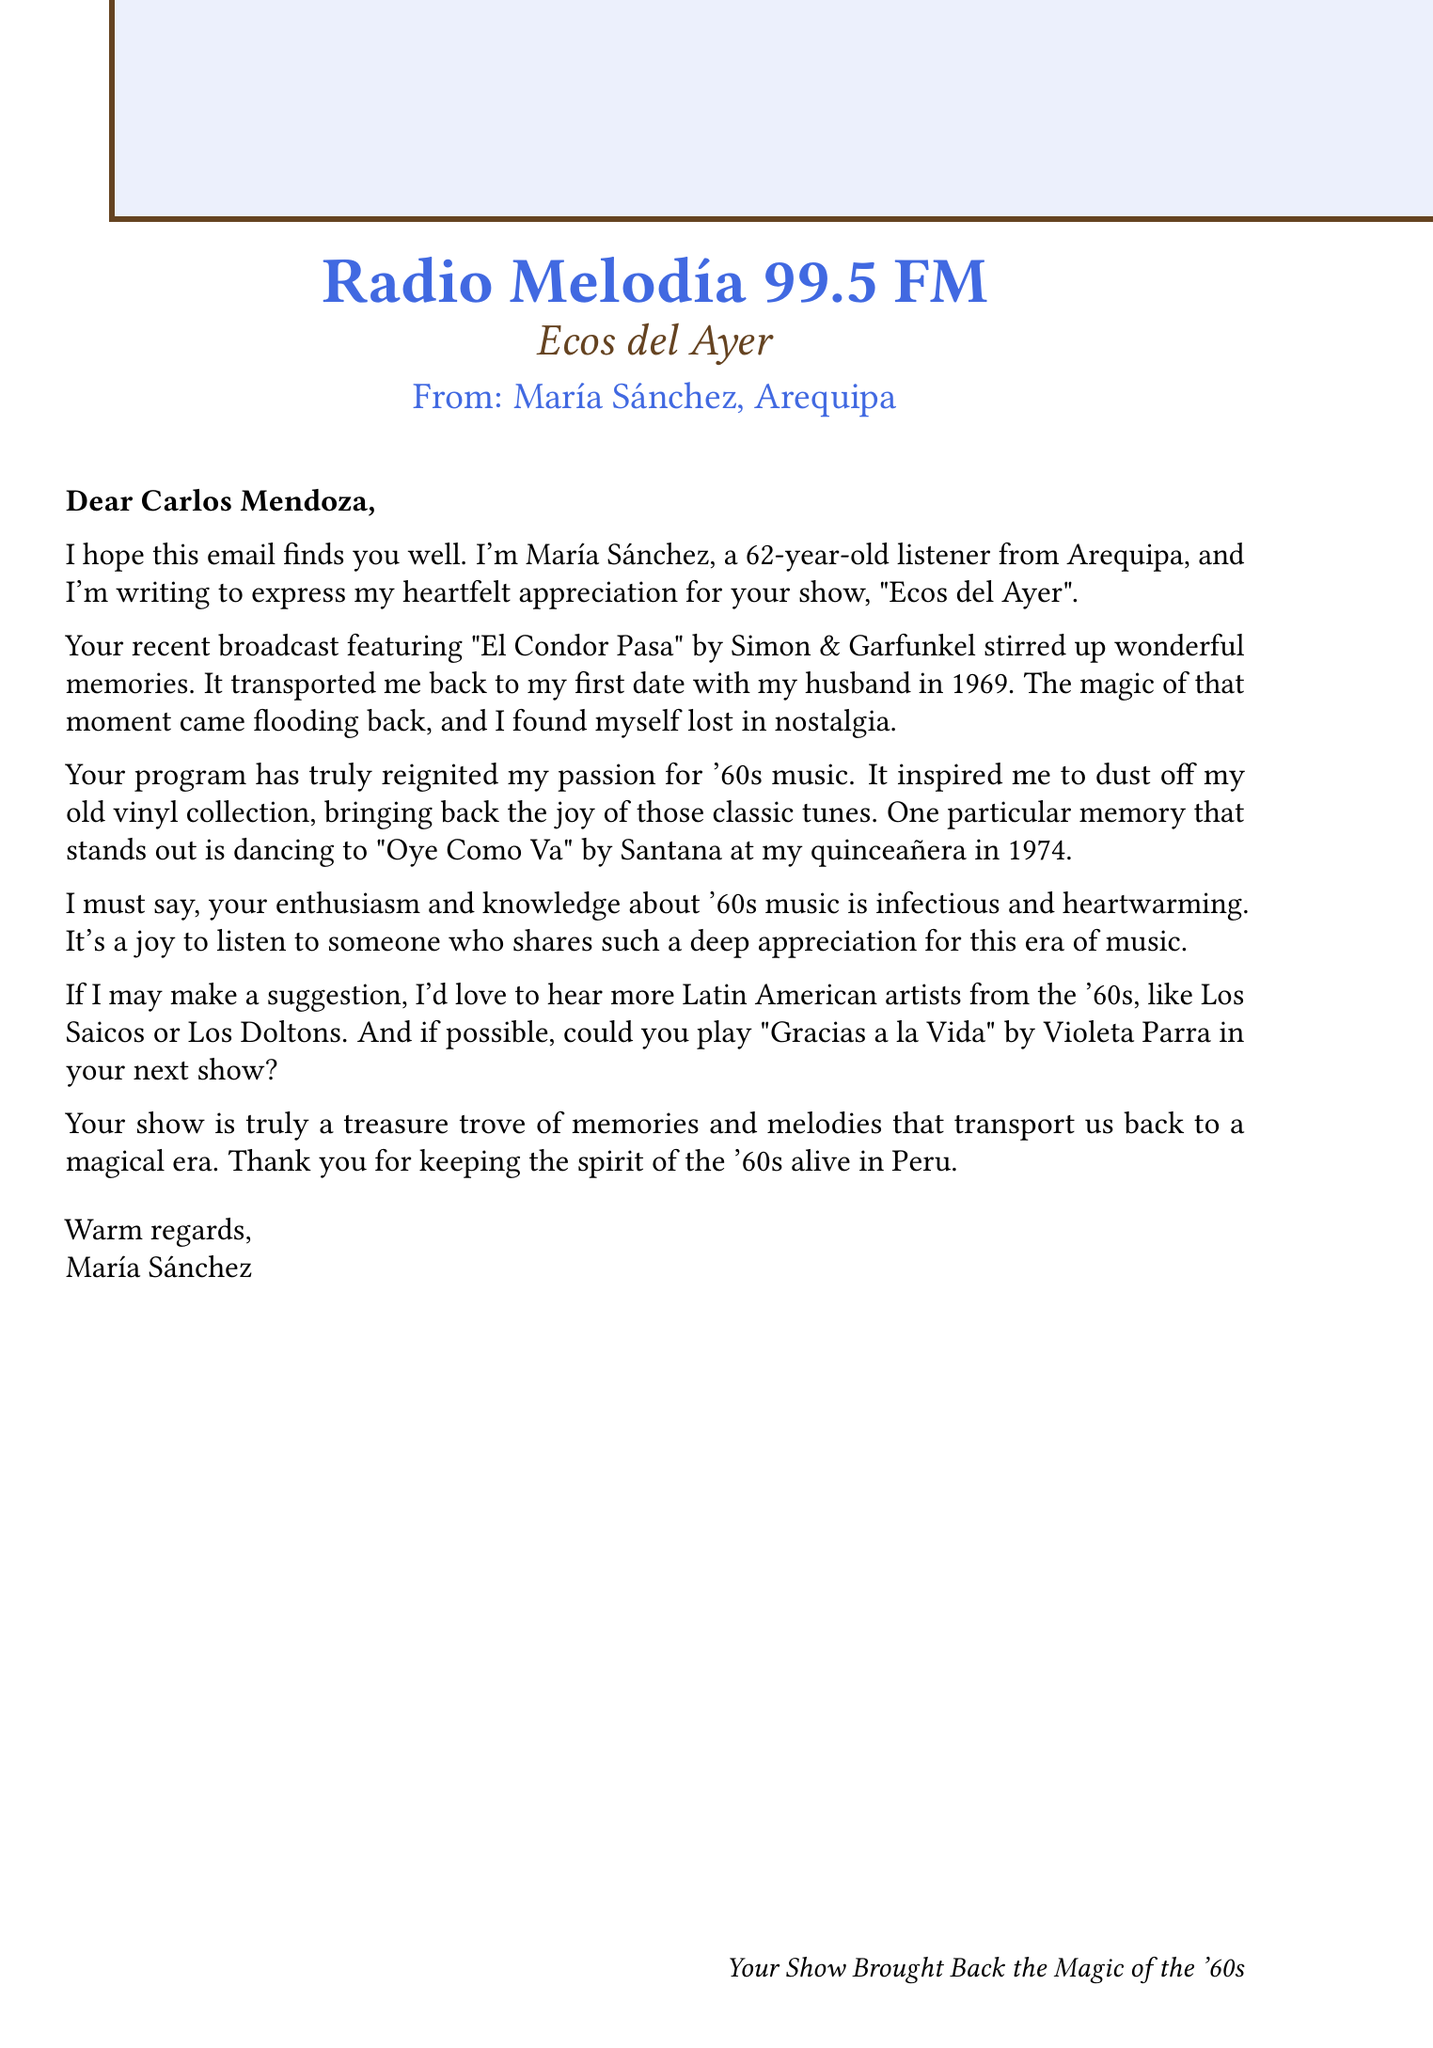What is the name of the listener? The listener's name is mentioned at the beginning of the email.
Answer: María Sánchez How old is María Sánchez? The age of the listener is stated in the document.
Answer: 62 What is the favorite song mentioned by María? The favorite song is explicitly noted in the email.
Answer: El Condor Pasa by Simon & Garfunkel When did María go on her first date? The document provides a specific year related to the personal memory.
Answer: 1969 Which song does María request to be played next? The email contains a specific song request.
Answer: Gracias a la Vida by Violeta Parra What memory does María associate with "Oye Como Va"? The document describes a specific event tied to the song.
Answer: Dancing at her quinceañera in 1974 What suggestion does María make for the show? The listener provides a recommendation about content for the radio show.
Answer: Feature more Latin American artists from the '60s What is the name of the radio show? The name of the show is mentioned prominently in the document.
Answer: Ecos del Ayer How does María describe the impact of the radio show? The email discusses the overall effect the show has had on the listener.
Answer: Reignited her passion for '60s music 